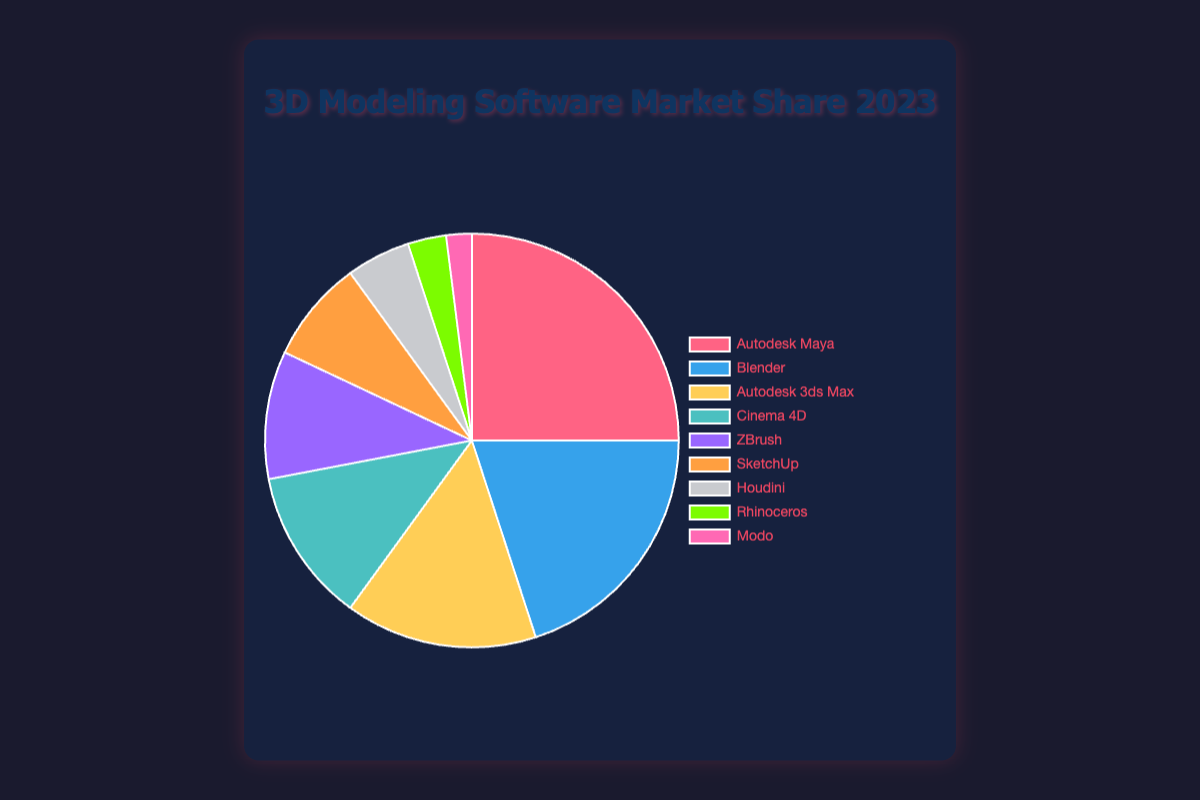Which software has the highest market share? The software with the highest market share is the one with the largest slice in the pie chart. Autodesk Maya has the highest share.
Answer: Autodesk Maya Which software has a lower market share, Houdini or Cinema 4D? By comparing the sizes of the pie slices or reading the legend, Houdini has a smaller slice at 5% compared to Cinema 4D’s 12%.
Answer: Houdini What is the combined market share of Blender and ZBrush? Sum the market shares of Blender and ZBrush: 20% + 10% = 30%.
Answer: 30% Which software has a market share that is one-third of Blender’s share? Blender has a market share of 20%. One-third of 20% is approximately 6.67%. SketchUp with 8% is the closest to one-third of Blender’s share.
Answer: SketchUp How much more market share does Autodesk Maya have compared to Rhinoceros? Subtract Rhinoceros’s share (3%) from Autodesk Maya’s share (25%): 25% - 3% = 22%.
Answer: 22% Which software has the smallest market share and what color represents it in the chart? The smallest slice in the pie chart represents Modo with 2%, and it is colored pink.
Answer: Modo, pink Is the market share of Autodesk 3ds Max greater than the total market share of SketchUp and Rhinoceros combined? Add the shares of SketchUp and Rhinoceros: 8% + 3% = 11%, then compare with Autodesk 3ds Max’s 15%. Autodesk 3ds Max's share is greater.
Answer: Yes Which software has a market share closest to twice the market share of Houdini? Houdini’s share is 5%. Twice that is 10%, which matches the market share of ZBrush.
Answer: ZBrush What is the difference in market share between the second and third most popular software? The second most popular is Blender (20%) and the third is Autodesk 3ds Max (15%). The difference is 20% - 15% = 5%.
Answer: 5% What is the combined market share of the three least popular software? Sum the market shares of Houdini (5%), Rhinoceros (3%), and Modo (2%): 5% + 3% + 2% = 10%.
Answer: 10% 